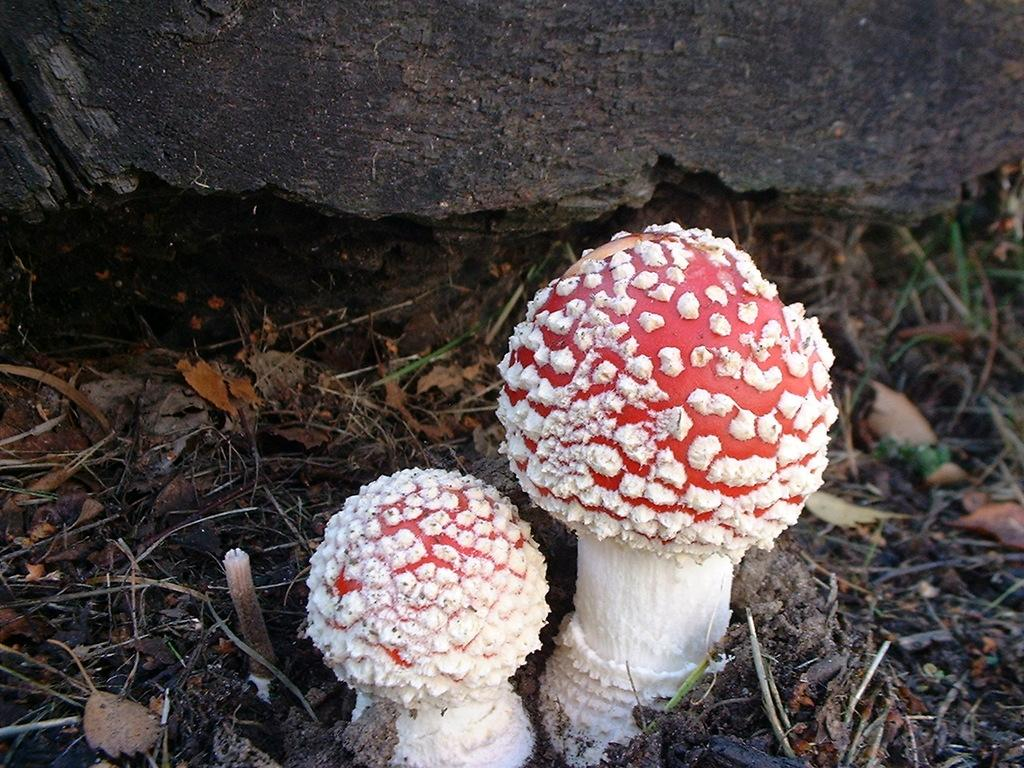What type of fungi can be seen in the image? There are mushrooms in the image. What colors are the mushrooms in the image? The mushrooms are in white and red colors. What natural elements are present at the bottom of the image? Dry leaves and twigs are present at the bottom of the image. What geological feature can be seen in the background of the image? There is a rock visible in the background of the image. How long does it take for the advertisement to appear in the image? There is no advertisement present in the image. Can you tell me the distance between the airport and the mushrooms in the image? There is no airport present in the image, so it is not possible to determine the distance between the airport and the mushrooms. 